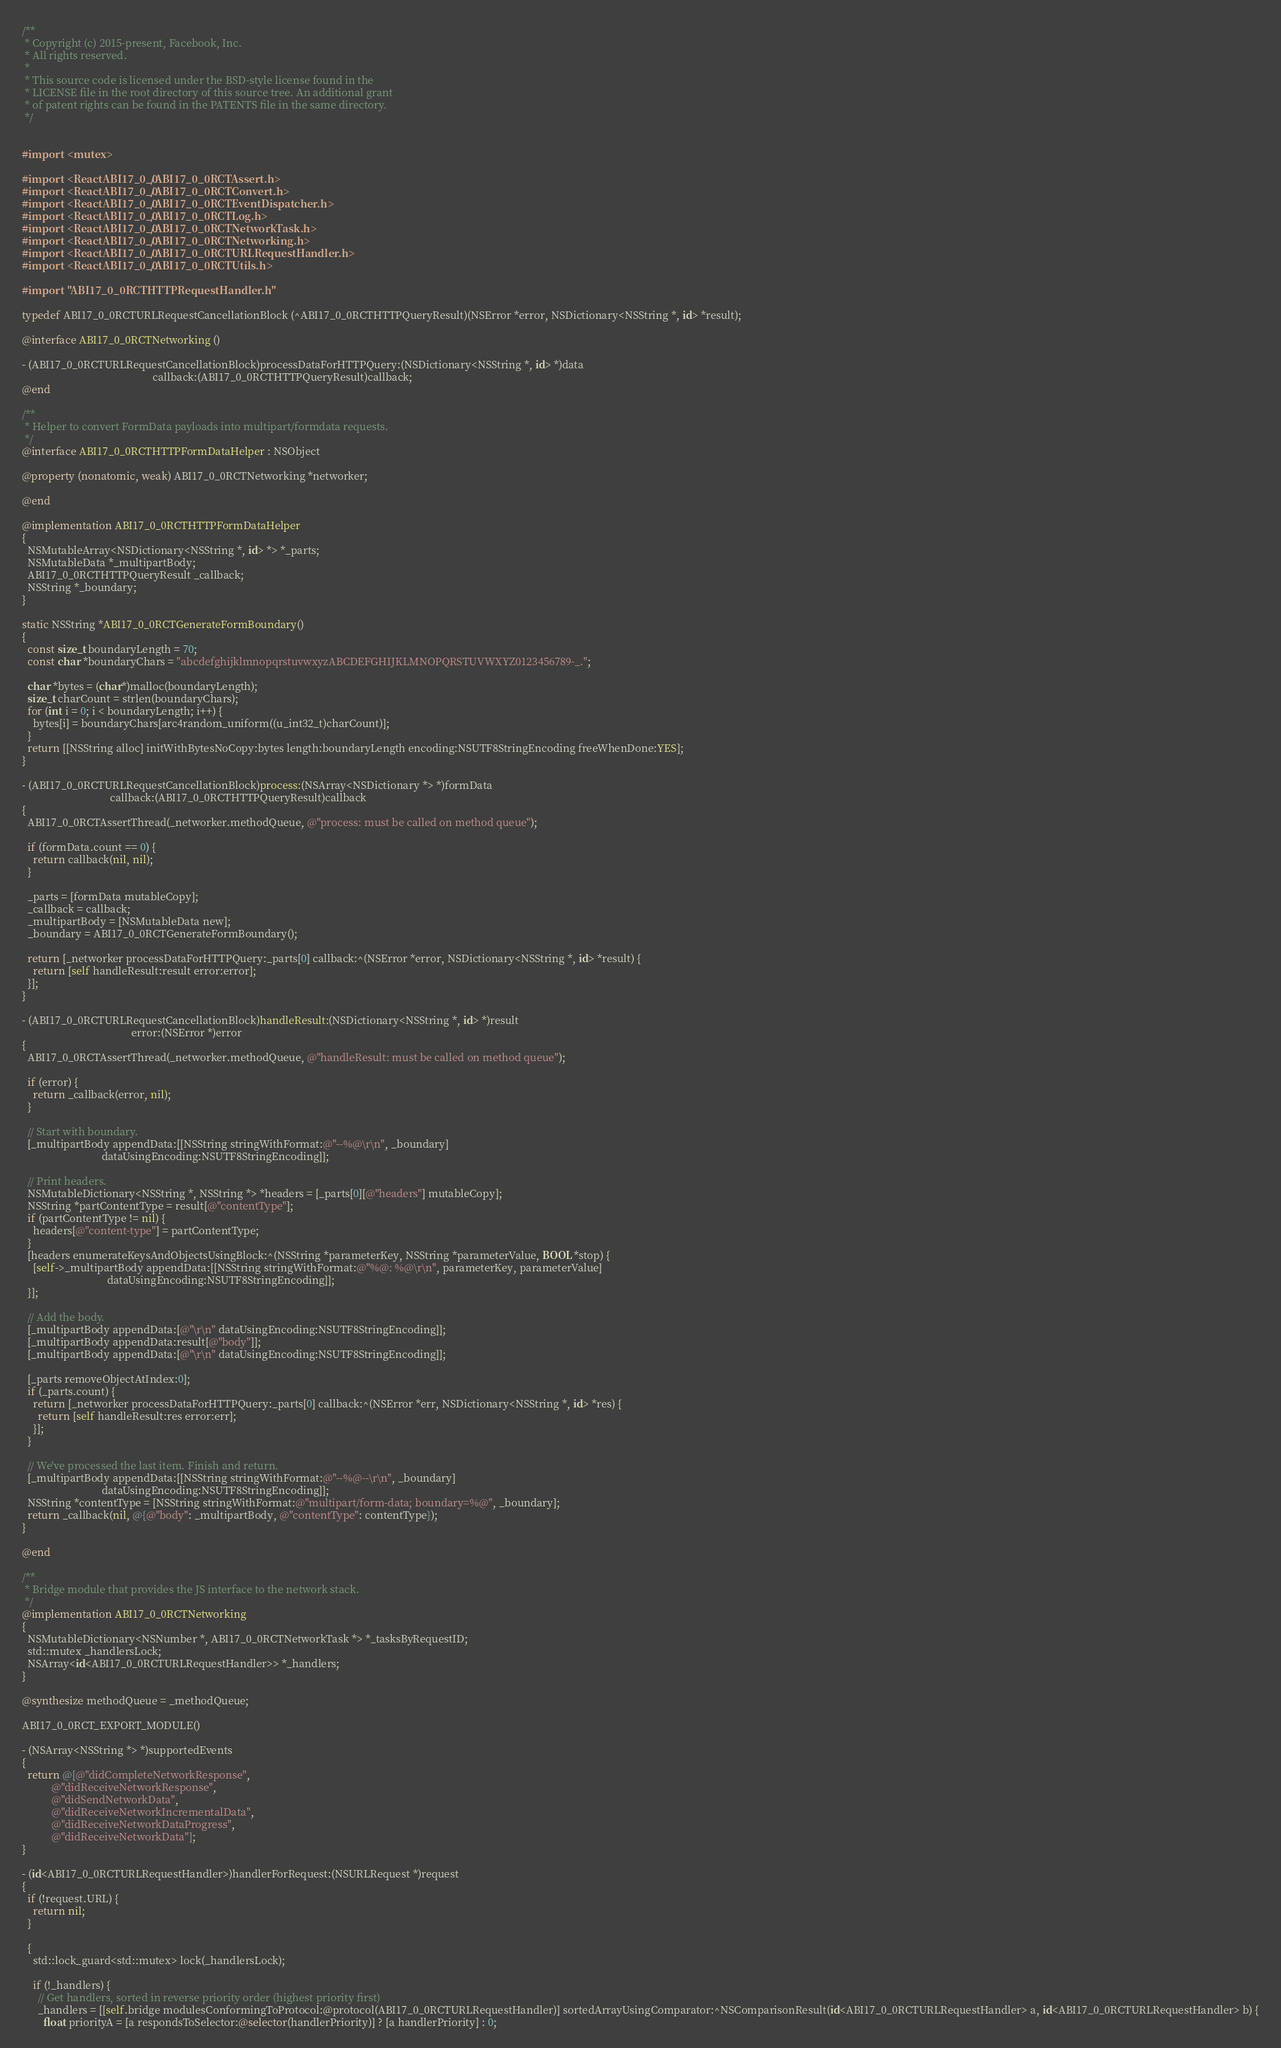Convert code to text. <code><loc_0><loc_0><loc_500><loc_500><_ObjectiveC_>/**
 * Copyright (c) 2015-present, Facebook, Inc.
 * All rights reserved.
 *
 * This source code is licensed under the BSD-style license found in the
 * LICENSE file in the root directory of this source tree. An additional grant
 * of patent rights can be found in the PATENTS file in the same directory.
 */


#import <mutex>

#import <ReactABI17_0_0/ABI17_0_0RCTAssert.h>
#import <ReactABI17_0_0/ABI17_0_0RCTConvert.h>
#import <ReactABI17_0_0/ABI17_0_0RCTEventDispatcher.h>
#import <ReactABI17_0_0/ABI17_0_0RCTLog.h>
#import <ReactABI17_0_0/ABI17_0_0RCTNetworkTask.h>
#import <ReactABI17_0_0/ABI17_0_0RCTNetworking.h>
#import <ReactABI17_0_0/ABI17_0_0RCTURLRequestHandler.h>
#import <ReactABI17_0_0/ABI17_0_0RCTUtils.h>

#import "ABI17_0_0RCTHTTPRequestHandler.h"

typedef ABI17_0_0RCTURLRequestCancellationBlock (^ABI17_0_0RCTHTTPQueryResult)(NSError *error, NSDictionary<NSString *, id> *result);

@interface ABI17_0_0RCTNetworking ()

- (ABI17_0_0RCTURLRequestCancellationBlock)processDataForHTTPQuery:(NSDictionary<NSString *, id> *)data
                                                 callback:(ABI17_0_0RCTHTTPQueryResult)callback;
@end

/**
 * Helper to convert FormData payloads into multipart/formdata requests.
 */
@interface ABI17_0_0RCTHTTPFormDataHelper : NSObject

@property (nonatomic, weak) ABI17_0_0RCTNetworking *networker;

@end

@implementation ABI17_0_0RCTHTTPFormDataHelper
{
  NSMutableArray<NSDictionary<NSString *, id> *> *_parts;
  NSMutableData *_multipartBody;
  ABI17_0_0RCTHTTPQueryResult _callback;
  NSString *_boundary;
}

static NSString *ABI17_0_0RCTGenerateFormBoundary()
{
  const size_t boundaryLength = 70;
  const char *boundaryChars = "abcdefghijklmnopqrstuvwxyzABCDEFGHIJKLMNOPQRSTUVWXYZ0123456789-_.";

  char *bytes = (char*)malloc(boundaryLength);
  size_t charCount = strlen(boundaryChars);
  for (int i = 0; i < boundaryLength; i++) {
    bytes[i] = boundaryChars[arc4random_uniform((u_int32_t)charCount)];
  }
  return [[NSString alloc] initWithBytesNoCopy:bytes length:boundaryLength encoding:NSUTF8StringEncoding freeWhenDone:YES];
}

- (ABI17_0_0RCTURLRequestCancellationBlock)process:(NSArray<NSDictionary *> *)formData
                                 callback:(ABI17_0_0RCTHTTPQueryResult)callback
{
  ABI17_0_0RCTAssertThread(_networker.methodQueue, @"process: must be called on method queue");

  if (formData.count == 0) {
    return callback(nil, nil);
  }

  _parts = [formData mutableCopy];
  _callback = callback;
  _multipartBody = [NSMutableData new];
  _boundary = ABI17_0_0RCTGenerateFormBoundary();

  return [_networker processDataForHTTPQuery:_parts[0] callback:^(NSError *error, NSDictionary<NSString *, id> *result) {
    return [self handleResult:result error:error];
  }];
}

- (ABI17_0_0RCTURLRequestCancellationBlock)handleResult:(NSDictionary<NSString *, id> *)result
                                         error:(NSError *)error
{
  ABI17_0_0RCTAssertThread(_networker.methodQueue, @"handleResult: must be called on method queue");

  if (error) {
    return _callback(error, nil);
  }

  // Start with boundary.
  [_multipartBody appendData:[[NSString stringWithFormat:@"--%@\r\n", _boundary]
                              dataUsingEncoding:NSUTF8StringEncoding]];

  // Print headers.
  NSMutableDictionary<NSString *, NSString *> *headers = [_parts[0][@"headers"] mutableCopy];
  NSString *partContentType = result[@"contentType"];
  if (partContentType != nil) {
    headers[@"content-type"] = partContentType;
  }
  [headers enumerateKeysAndObjectsUsingBlock:^(NSString *parameterKey, NSString *parameterValue, BOOL *stop) {
    [self->_multipartBody appendData:[[NSString stringWithFormat:@"%@: %@\r\n", parameterKey, parameterValue]
                                dataUsingEncoding:NSUTF8StringEncoding]];
  }];

  // Add the body.
  [_multipartBody appendData:[@"\r\n" dataUsingEncoding:NSUTF8StringEncoding]];
  [_multipartBody appendData:result[@"body"]];
  [_multipartBody appendData:[@"\r\n" dataUsingEncoding:NSUTF8StringEncoding]];

  [_parts removeObjectAtIndex:0];
  if (_parts.count) {
    return [_networker processDataForHTTPQuery:_parts[0] callback:^(NSError *err, NSDictionary<NSString *, id> *res) {
      return [self handleResult:res error:err];
    }];
  }

  // We've processed the last item. Finish and return.
  [_multipartBody appendData:[[NSString stringWithFormat:@"--%@--\r\n", _boundary]
                              dataUsingEncoding:NSUTF8StringEncoding]];
  NSString *contentType = [NSString stringWithFormat:@"multipart/form-data; boundary=%@", _boundary];
  return _callback(nil, @{@"body": _multipartBody, @"contentType": contentType});
}

@end

/**
 * Bridge module that provides the JS interface to the network stack.
 */
@implementation ABI17_0_0RCTNetworking
{
  NSMutableDictionary<NSNumber *, ABI17_0_0RCTNetworkTask *> *_tasksByRequestID;
  std::mutex _handlersLock;
  NSArray<id<ABI17_0_0RCTURLRequestHandler>> *_handlers;
}

@synthesize methodQueue = _methodQueue;

ABI17_0_0RCT_EXPORT_MODULE()

- (NSArray<NSString *> *)supportedEvents
{
  return @[@"didCompleteNetworkResponse",
           @"didReceiveNetworkResponse",
           @"didSendNetworkData",
           @"didReceiveNetworkIncrementalData",
           @"didReceiveNetworkDataProgress",
           @"didReceiveNetworkData"];
}

- (id<ABI17_0_0RCTURLRequestHandler>)handlerForRequest:(NSURLRequest *)request
{
  if (!request.URL) {
    return nil;
  }

  {
    std::lock_guard<std::mutex> lock(_handlersLock);

    if (!_handlers) {
      // Get handlers, sorted in reverse priority order (highest priority first)
      _handlers = [[self.bridge modulesConformingToProtocol:@protocol(ABI17_0_0RCTURLRequestHandler)] sortedArrayUsingComparator:^NSComparisonResult(id<ABI17_0_0RCTURLRequestHandler> a, id<ABI17_0_0RCTURLRequestHandler> b) {
        float priorityA = [a respondsToSelector:@selector(handlerPriority)] ? [a handlerPriority] : 0;</code> 